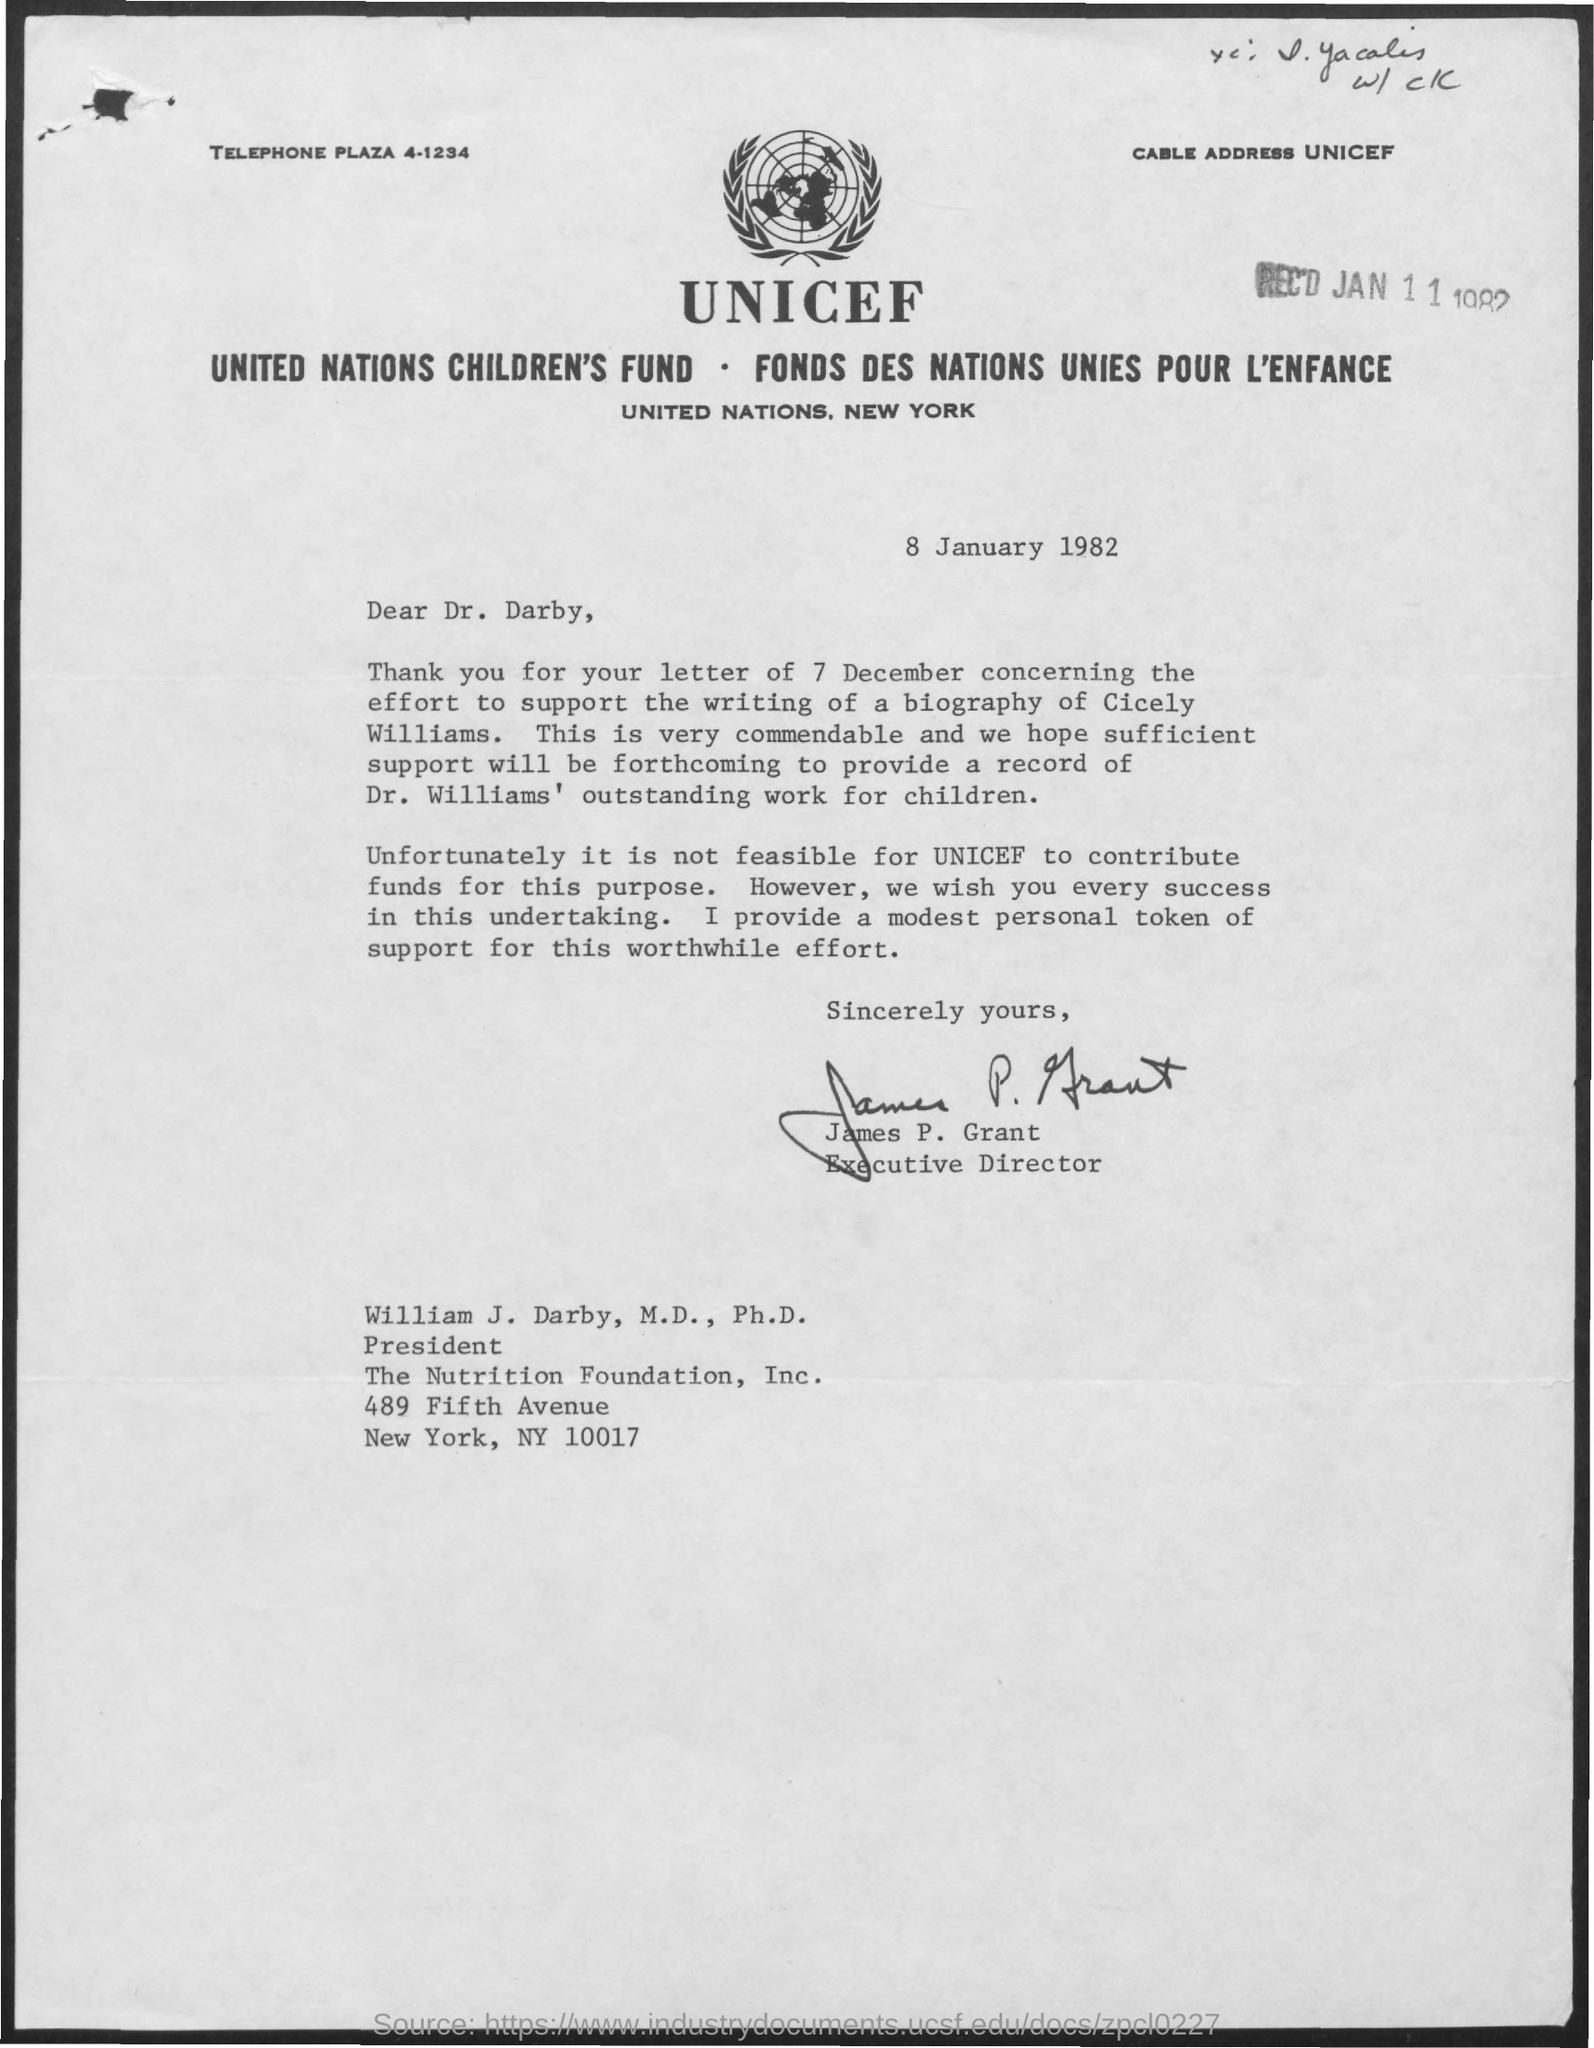Outline some significant characteristics in this image. The document mentions Dr. Darby as Dear. The document was signed by James P. Grant, the Executive Director. 